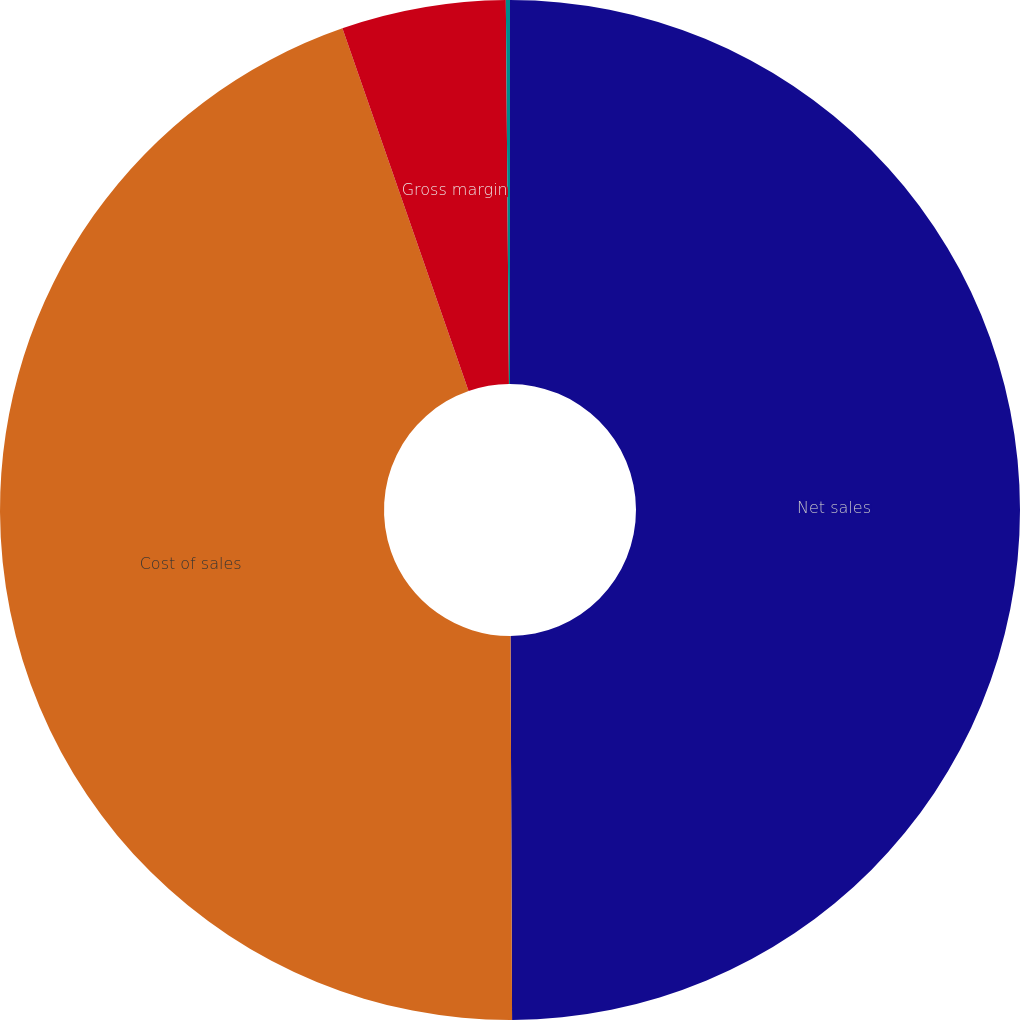Convert chart. <chart><loc_0><loc_0><loc_500><loc_500><pie_chart><fcel>Net sales<fcel>Cost of sales<fcel>Gross margin<fcel>Gross margin percentage<nl><fcel>49.94%<fcel>44.74%<fcel>5.2%<fcel>0.13%<nl></chart> 